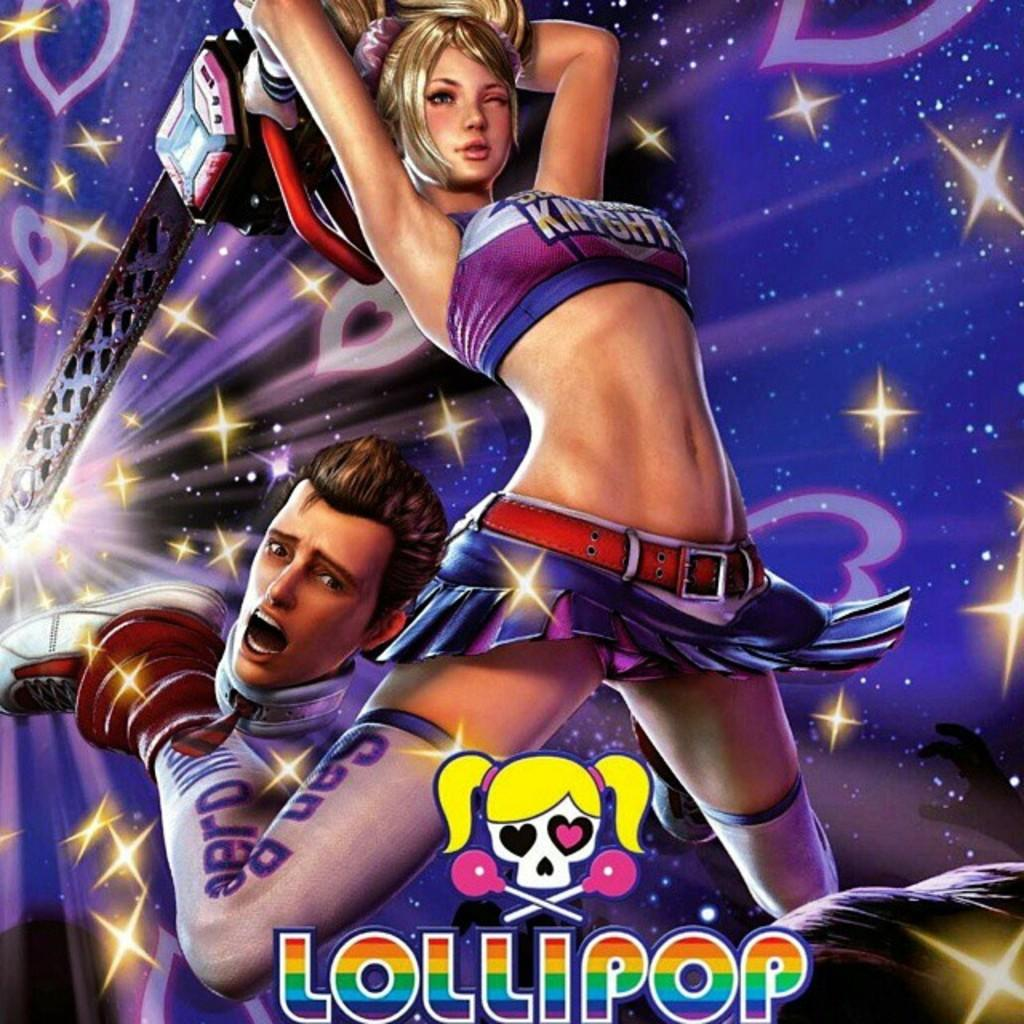<image>
Summarize the visual content of the image. Poster of two cartoons with the word "Lollipop" at the bottom. 